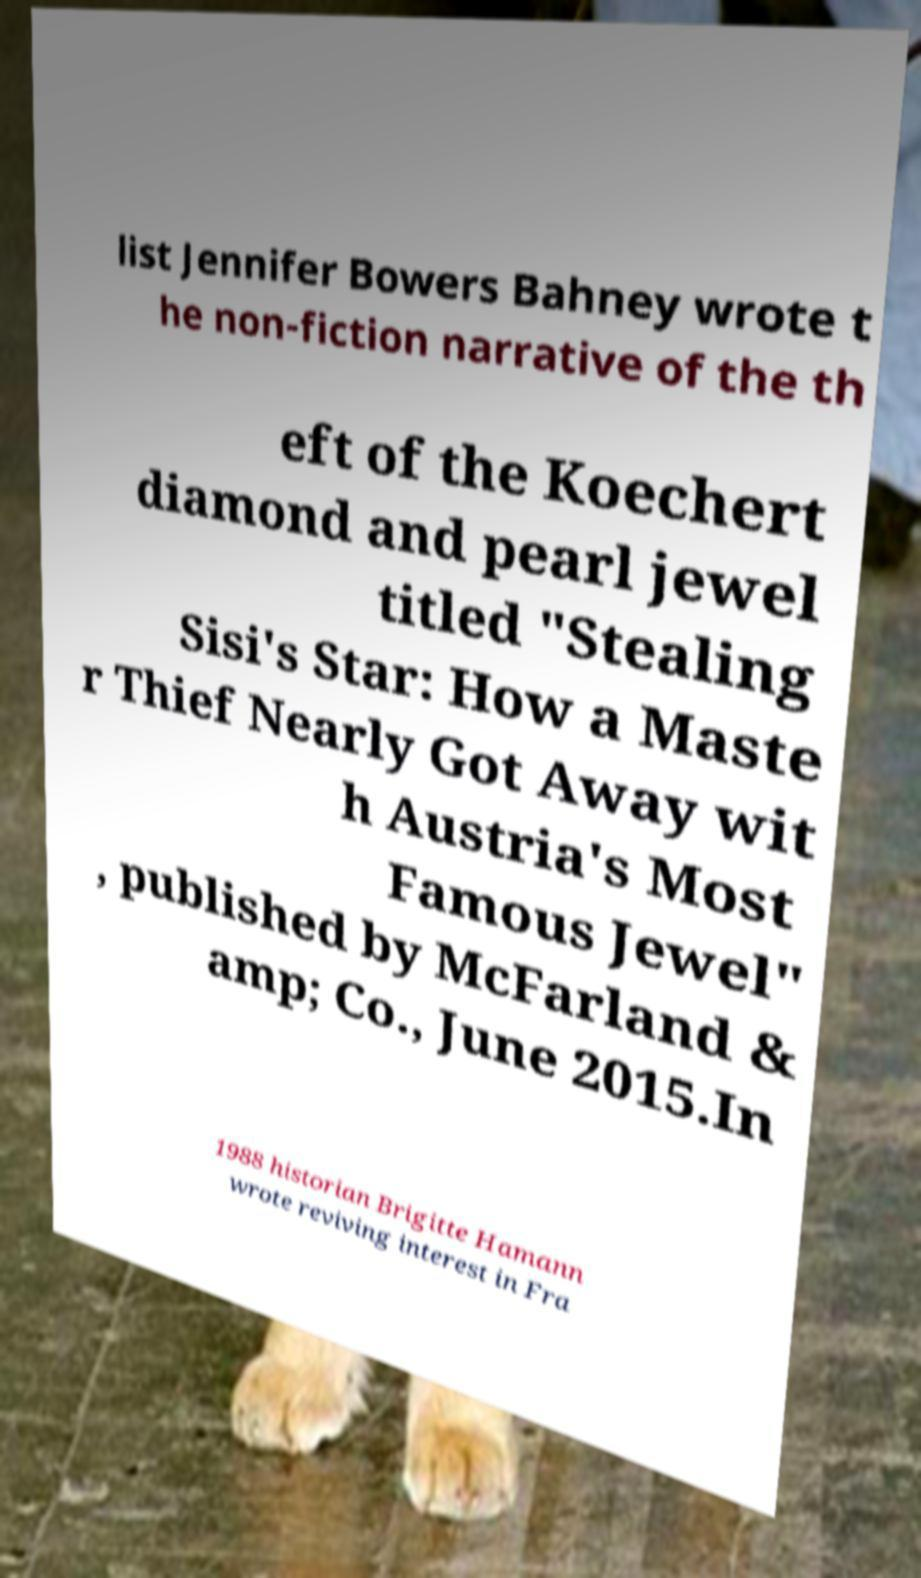Can you accurately transcribe the text from the provided image for me? list Jennifer Bowers Bahney wrote t he non-fiction narrative of the th eft of the Koechert diamond and pearl jewel titled "Stealing Sisi's Star: How a Maste r Thief Nearly Got Away wit h Austria's Most Famous Jewel" , published by McFarland & amp; Co., June 2015.In 1988 historian Brigitte Hamann wrote reviving interest in Fra 